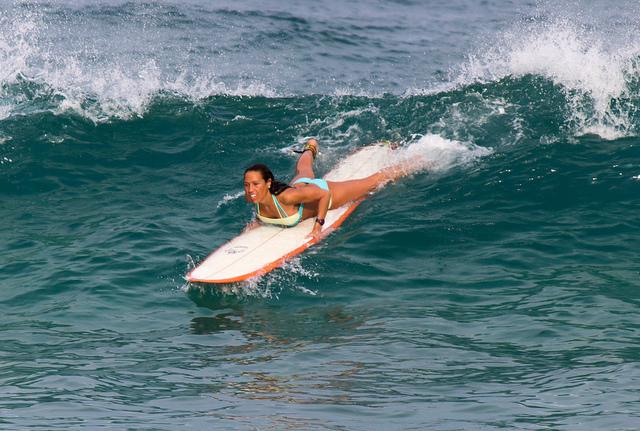What activity is this person doing?
Give a very brief answer. Surfing. Is the girl cold or hot?
Keep it brief. Hot. Is the water foamy?
Be succinct. Yes. Is this woman taking a bath?
Give a very brief answer. No. Is this person an experienced surfer?
Quick response, please. Yes. What color is the surfboard?
Quick response, please. White and orange. What is the woman riding on?
Concise answer only. Surfboard. What type of swimsuit is the woman wearing?
Write a very short answer. Bikini. What color is in a circle on the surfboard?
Give a very brief answer. White. Is this picture signed?
Be succinct. No. 